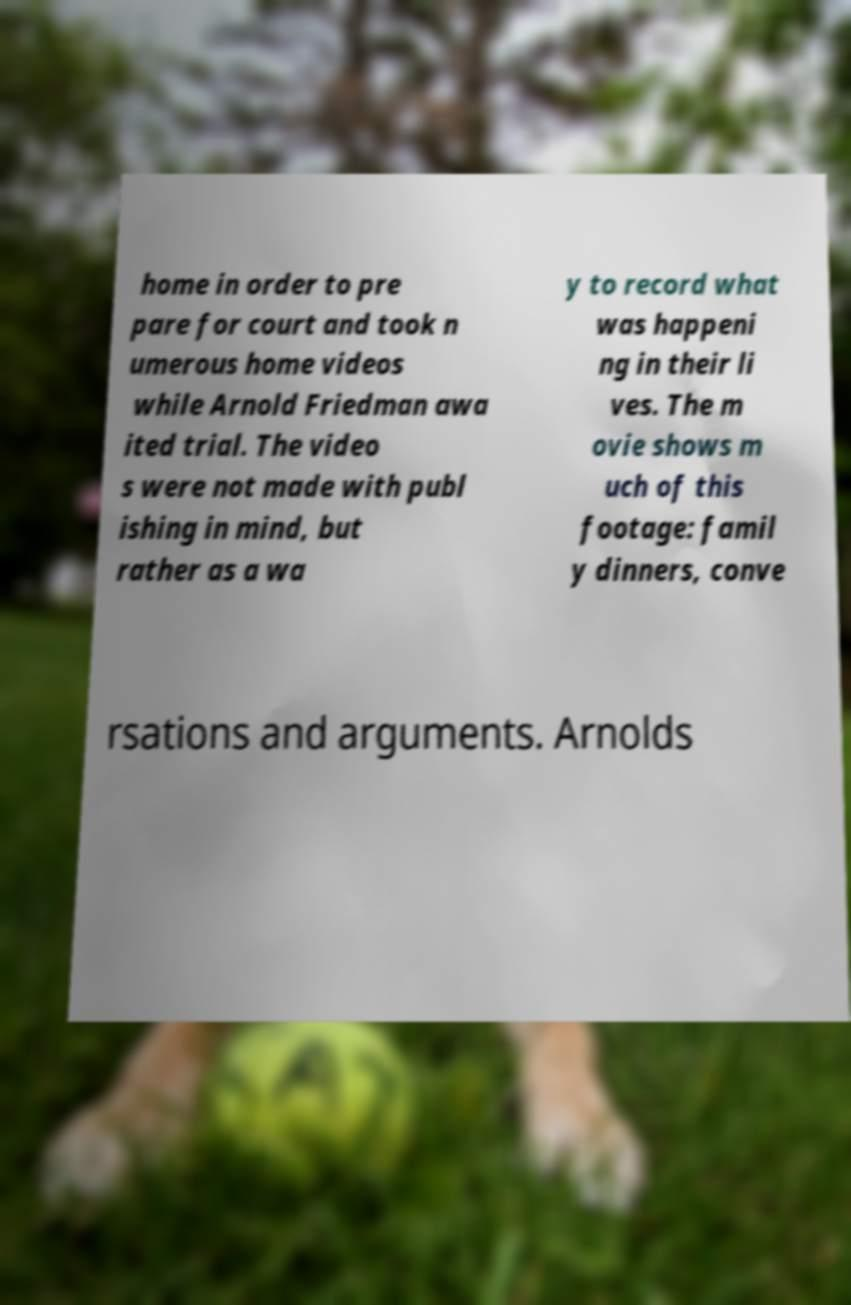Please identify and transcribe the text found in this image. home in order to pre pare for court and took n umerous home videos while Arnold Friedman awa ited trial. The video s were not made with publ ishing in mind, but rather as a wa y to record what was happeni ng in their li ves. The m ovie shows m uch of this footage: famil y dinners, conve rsations and arguments. Arnolds 